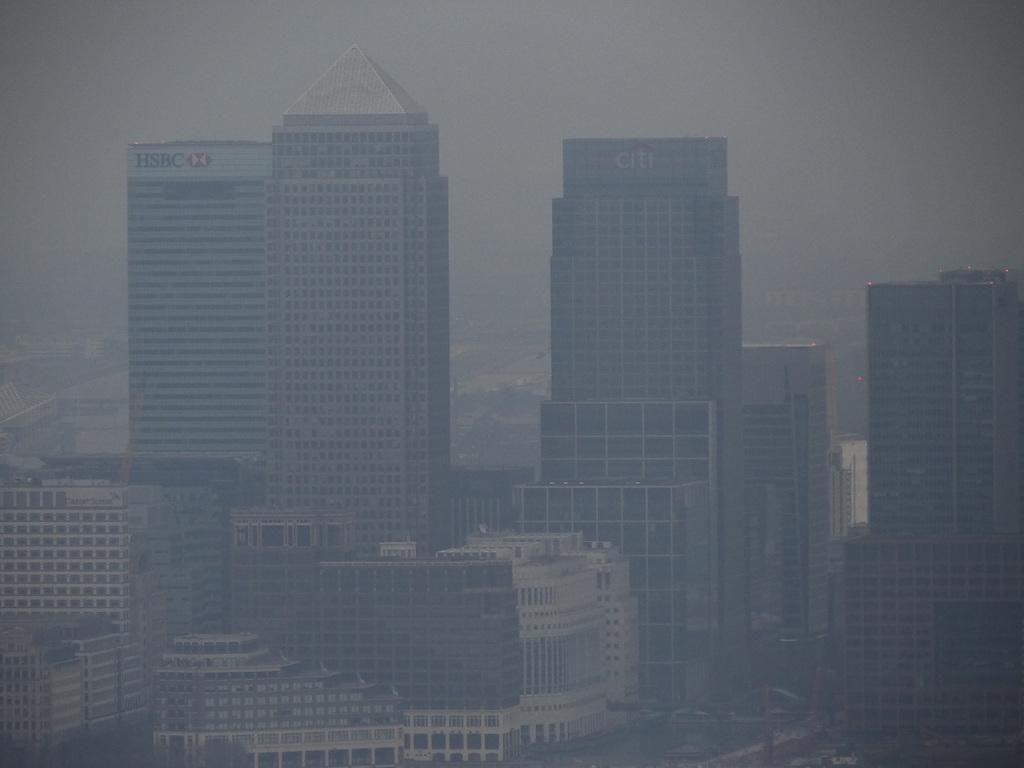What type of structures can be seen in the image? There are many buildings in the image. What kind of organizations are represented by these buildings? Most of the buildings are organizations. How many crates are stacked next to the buildings in the image? There are no crates present in the image. What type of skin can be seen on the buildings in the image? The buildings in the image are made of materials such as brick, concrete, or glass, and do not have skin. 